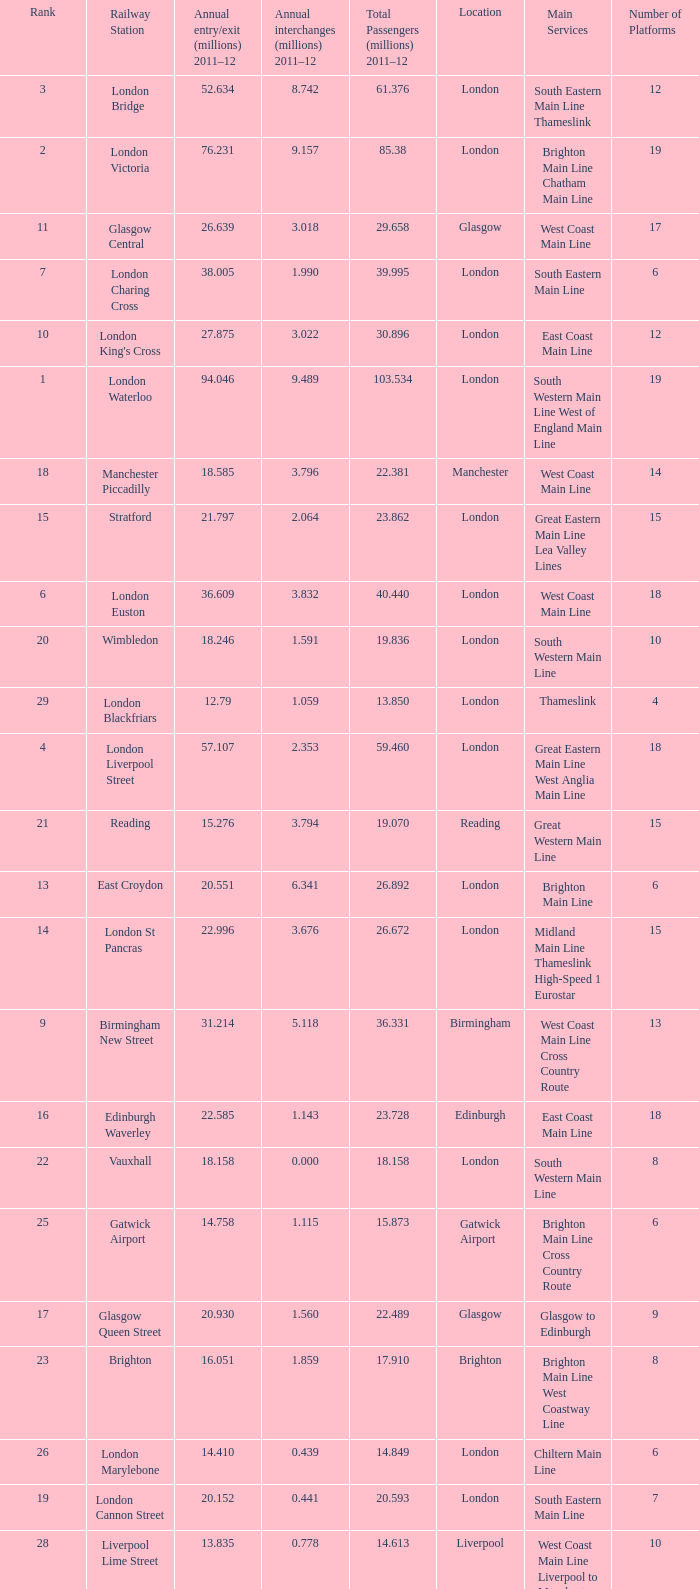What is the lowest rank of Gatwick Airport?  25.0. 